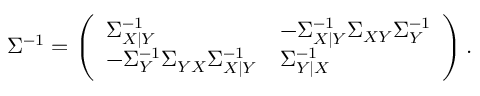<formula> <loc_0><loc_0><loc_500><loc_500>\begin{array} { r } { \Sigma ^ { - 1 } = \left ( \begin{array} { l l } { \Sigma _ { X | Y } ^ { - 1 } } & { - \Sigma _ { X | Y } ^ { - 1 } \Sigma _ { X Y } \Sigma _ { Y } ^ { - 1 } } \\ { - \Sigma _ { Y } ^ { - 1 } \Sigma _ { Y X } \Sigma _ { X | Y } ^ { - 1 } } & { \Sigma _ { Y | X } ^ { - 1 } } \end{array} \right ) . } \end{array}</formula> 